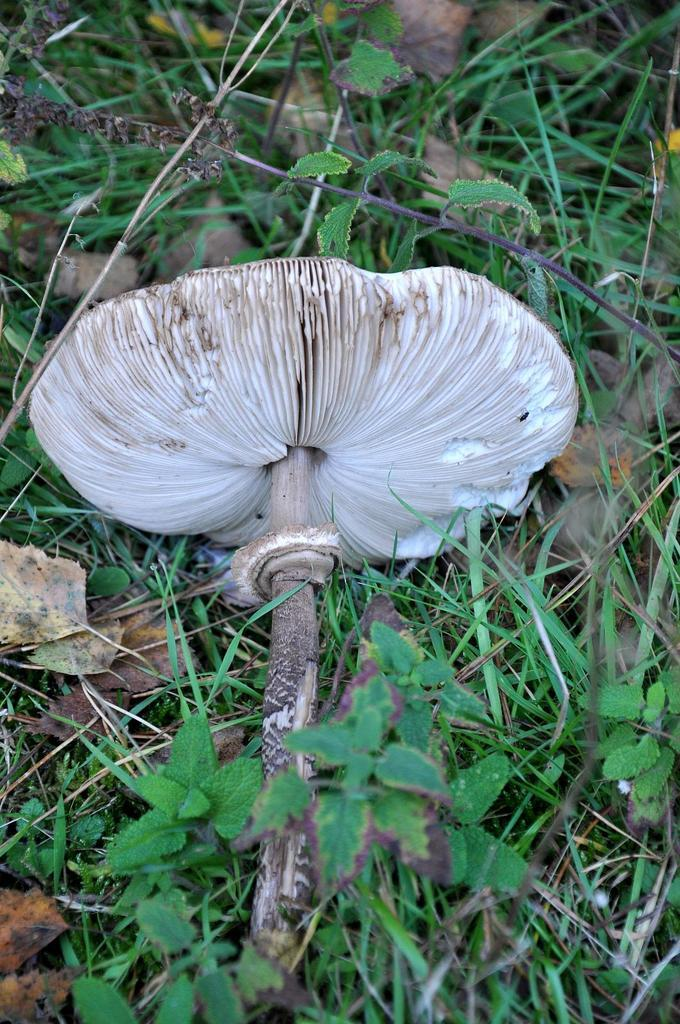What type of fungus can be seen in the image? There is a mushroom in the image. What other types of vegetation are present in the image? There are plants in the image. What type of ground cover is visible in the image? There is grass in the image. What type of jeans is the mushroom wearing in the image? There are no jeans present in the image, as the mushroom is a fungus and not a person. 